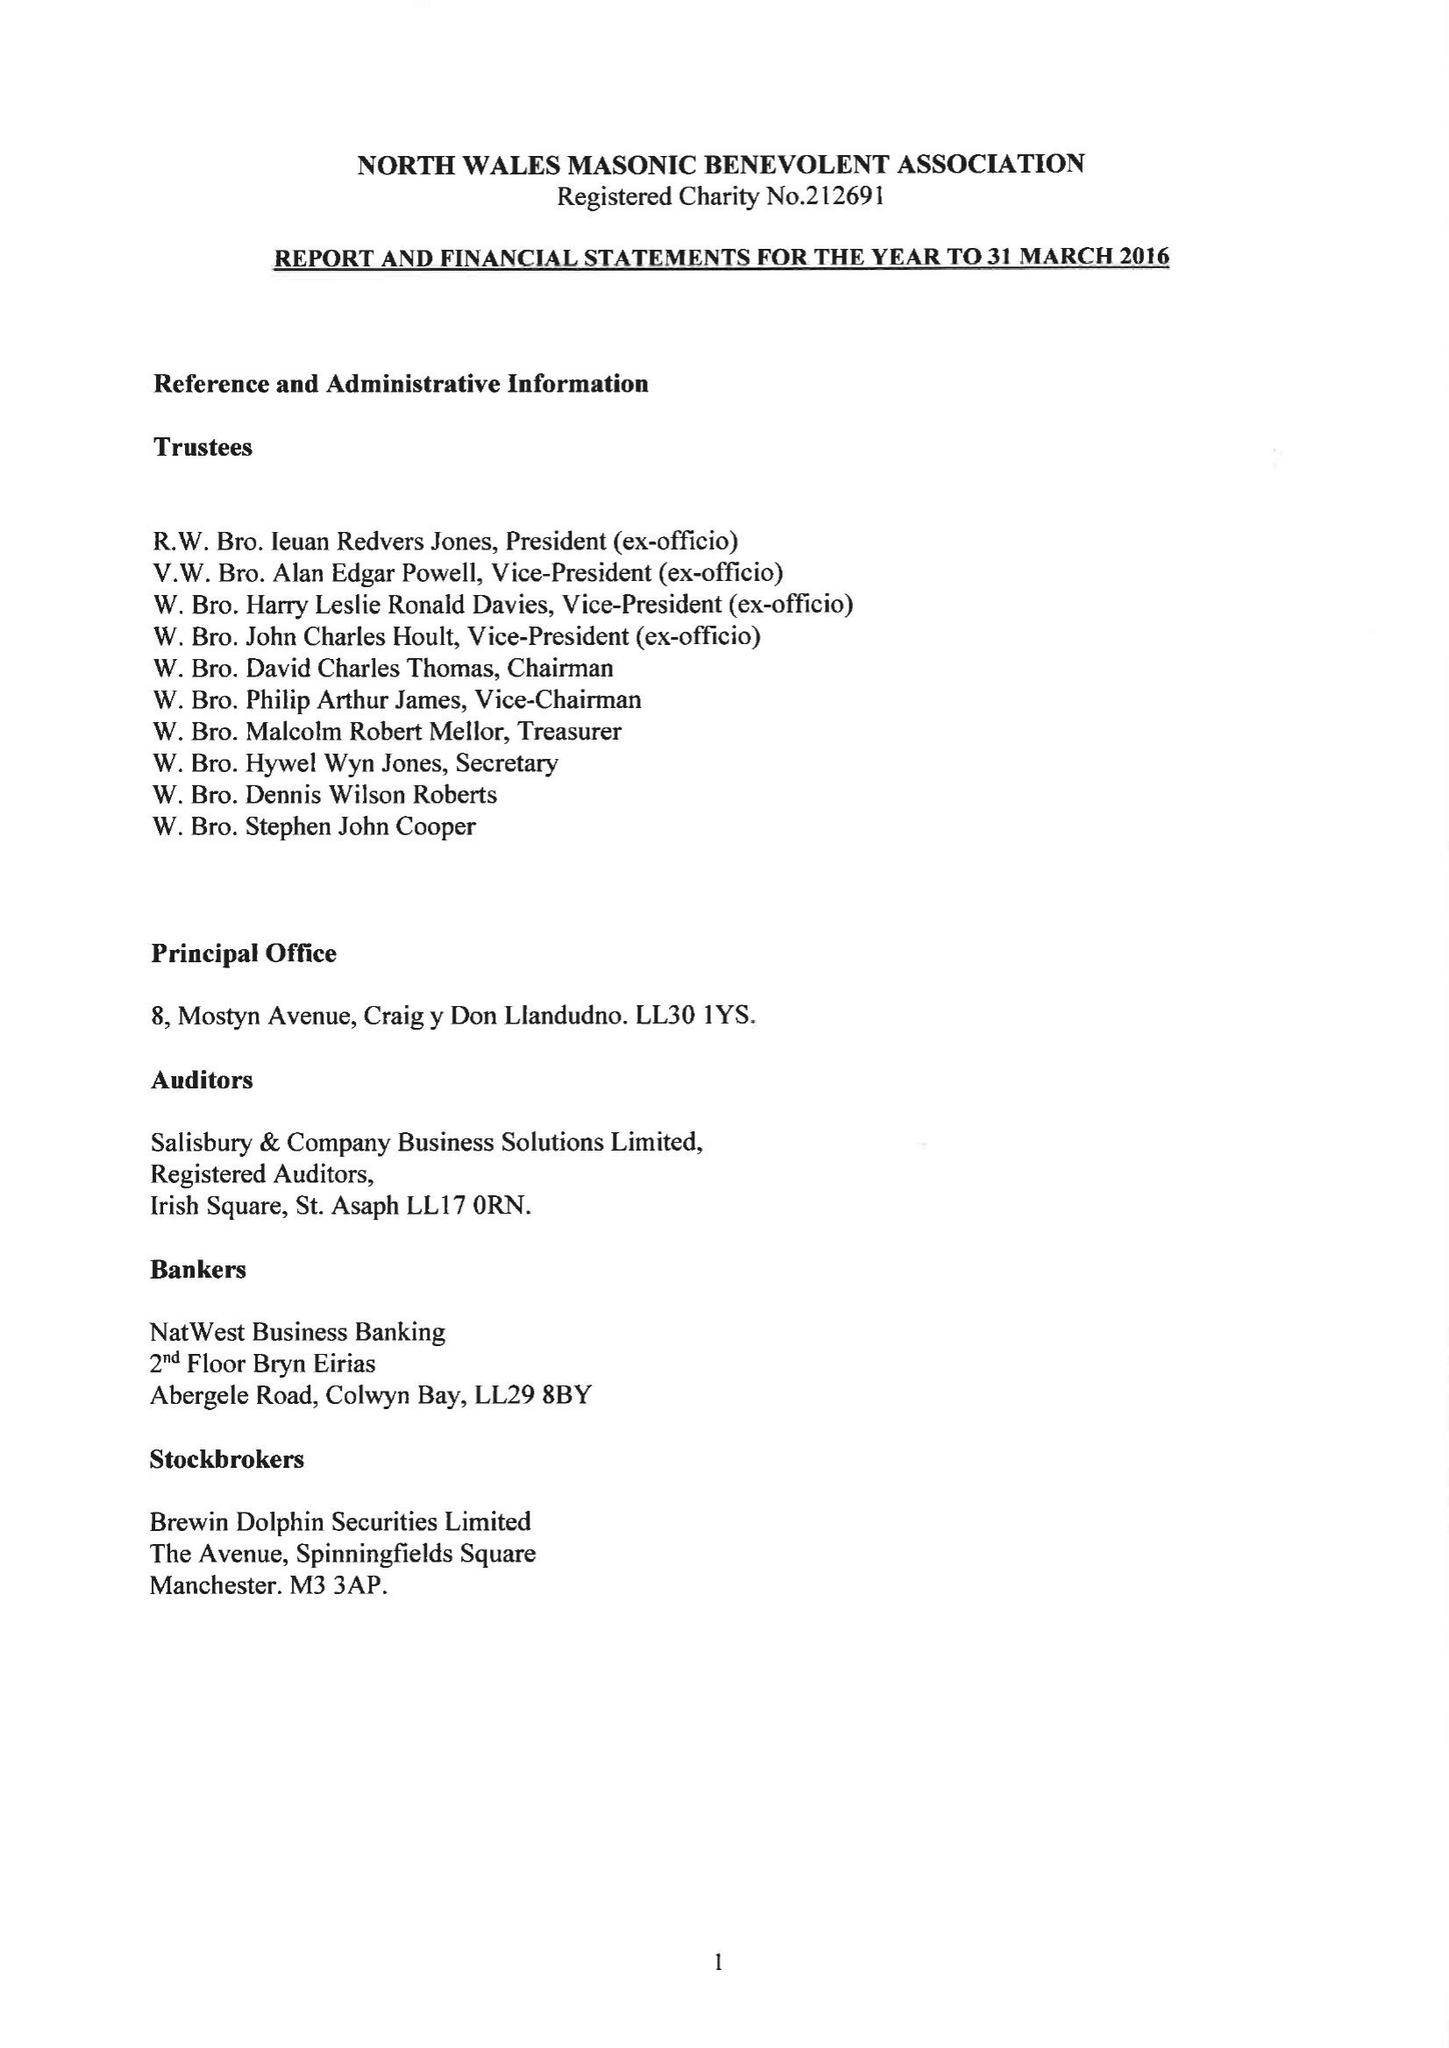What is the value for the charity_name?
Answer the question using a single word or phrase. The North Wales Masonic Benevolent Association 